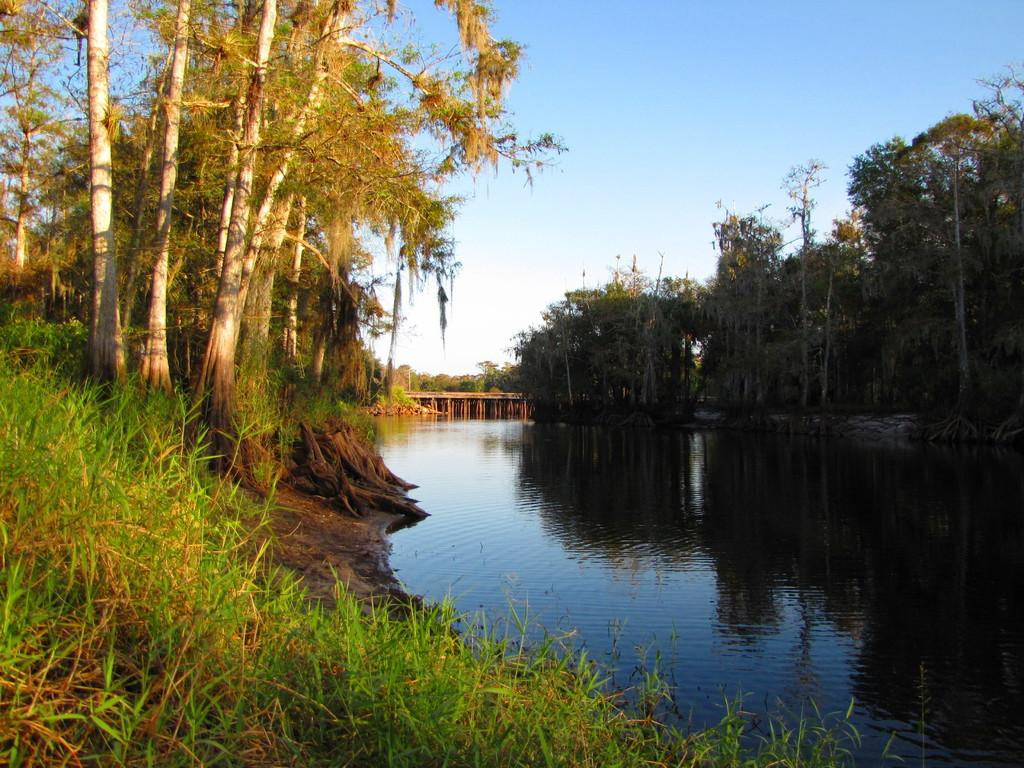What is visible in the foreground of the image? In the foreground of the image, there is grass, water, and trees. What can be seen in the background of the image? There is a bridge in the background of the image. What is visible above the bridge and trees? The sky is visible in the image. When was the image taken? The image was taken during the day. What type of pin can be seen holding the bridge together in the image? There is no pin visible in the image holding the bridge together; the bridge's construction is not shown in detail. How does the water in the image affect the brake system of the nearby vehicles? There are no vehicles or brake systems visible in the image, so it is impossible to determine any effects on them. 